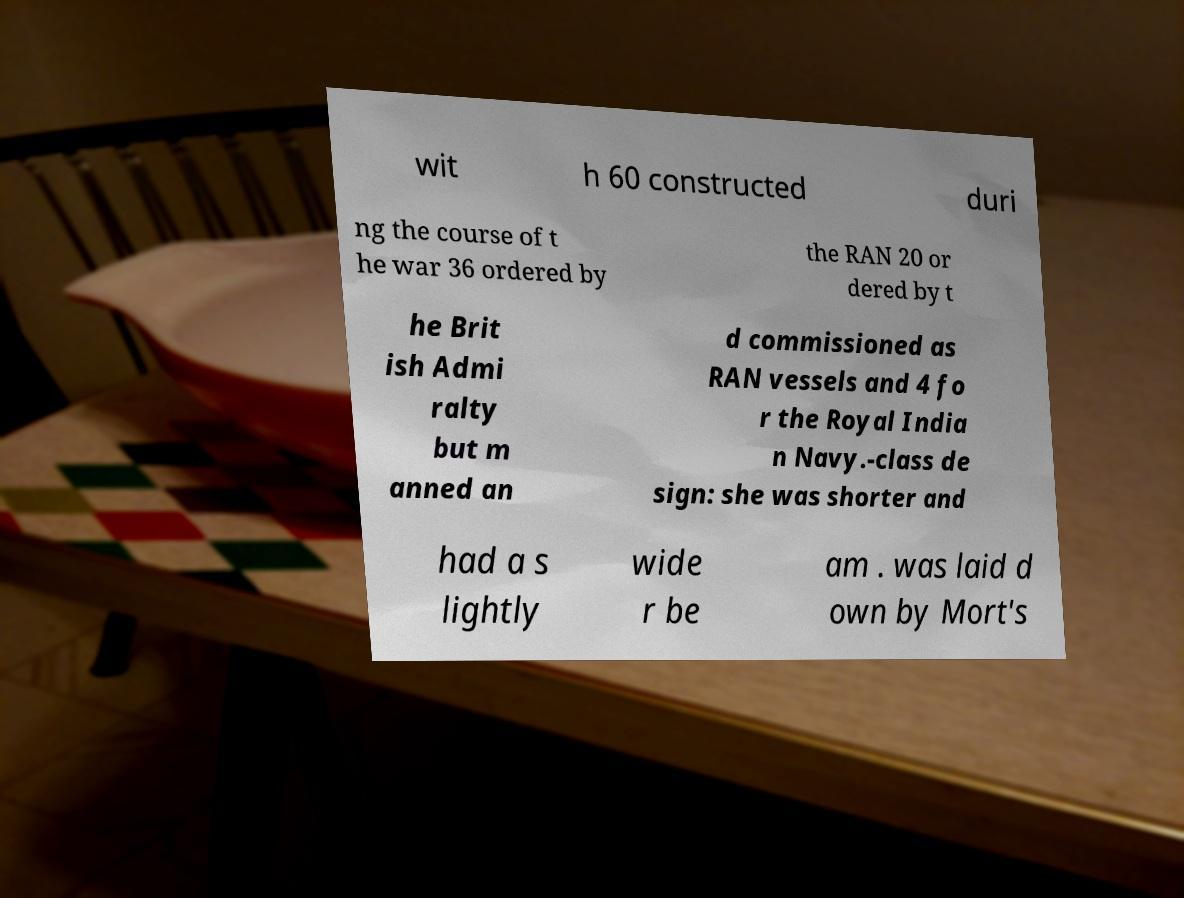There's text embedded in this image that I need extracted. Can you transcribe it verbatim? wit h 60 constructed duri ng the course of t he war 36 ordered by the RAN 20 or dered by t he Brit ish Admi ralty but m anned an d commissioned as RAN vessels and 4 fo r the Royal India n Navy.-class de sign: she was shorter and had a s lightly wide r be am . was laid d own by Mort's 